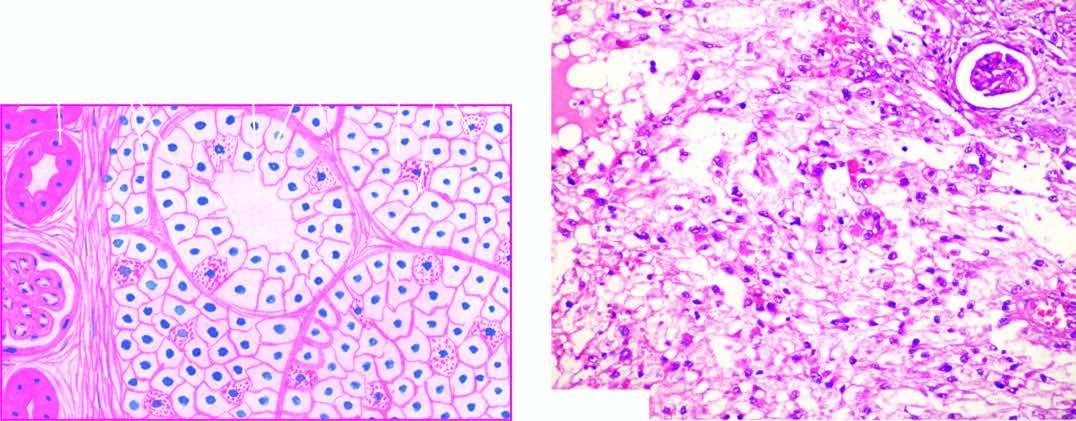what shows solid masses and acini of uniform-appearing tumour cells?
Answer the question using a single word or phrase. Tumour 